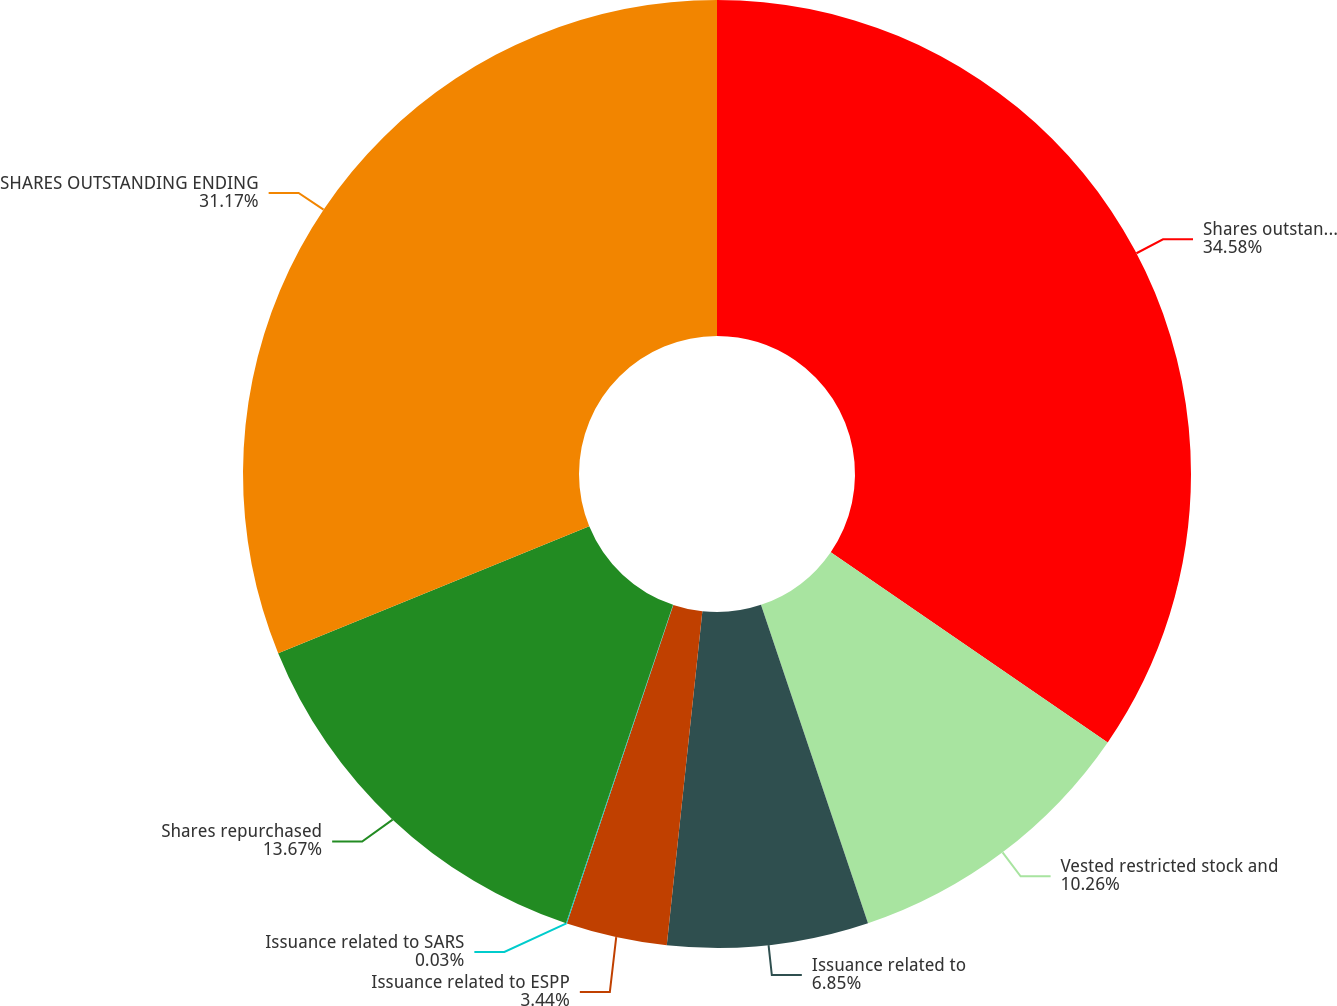Convert chart to OTSL. <chart><loc_0><loc_0><loc_500><loc_500><pie_chart><fcel>Shares outstanding beginning<fcel>Vested restricted stock and<fcel>Issuance related to<fcel>Issuance related to ESPP<fcel>Issuance related to SARS<fcel>Shares repurchased<fcel>SHARES OUTSTANDING ENDING<nl><fcel>34.58%<fcel>10.26%<fcel>6.85%<fcel>3.44%<fcel>0.03%<fcel>13.67%<fcel>31.17%<nl></chart> 